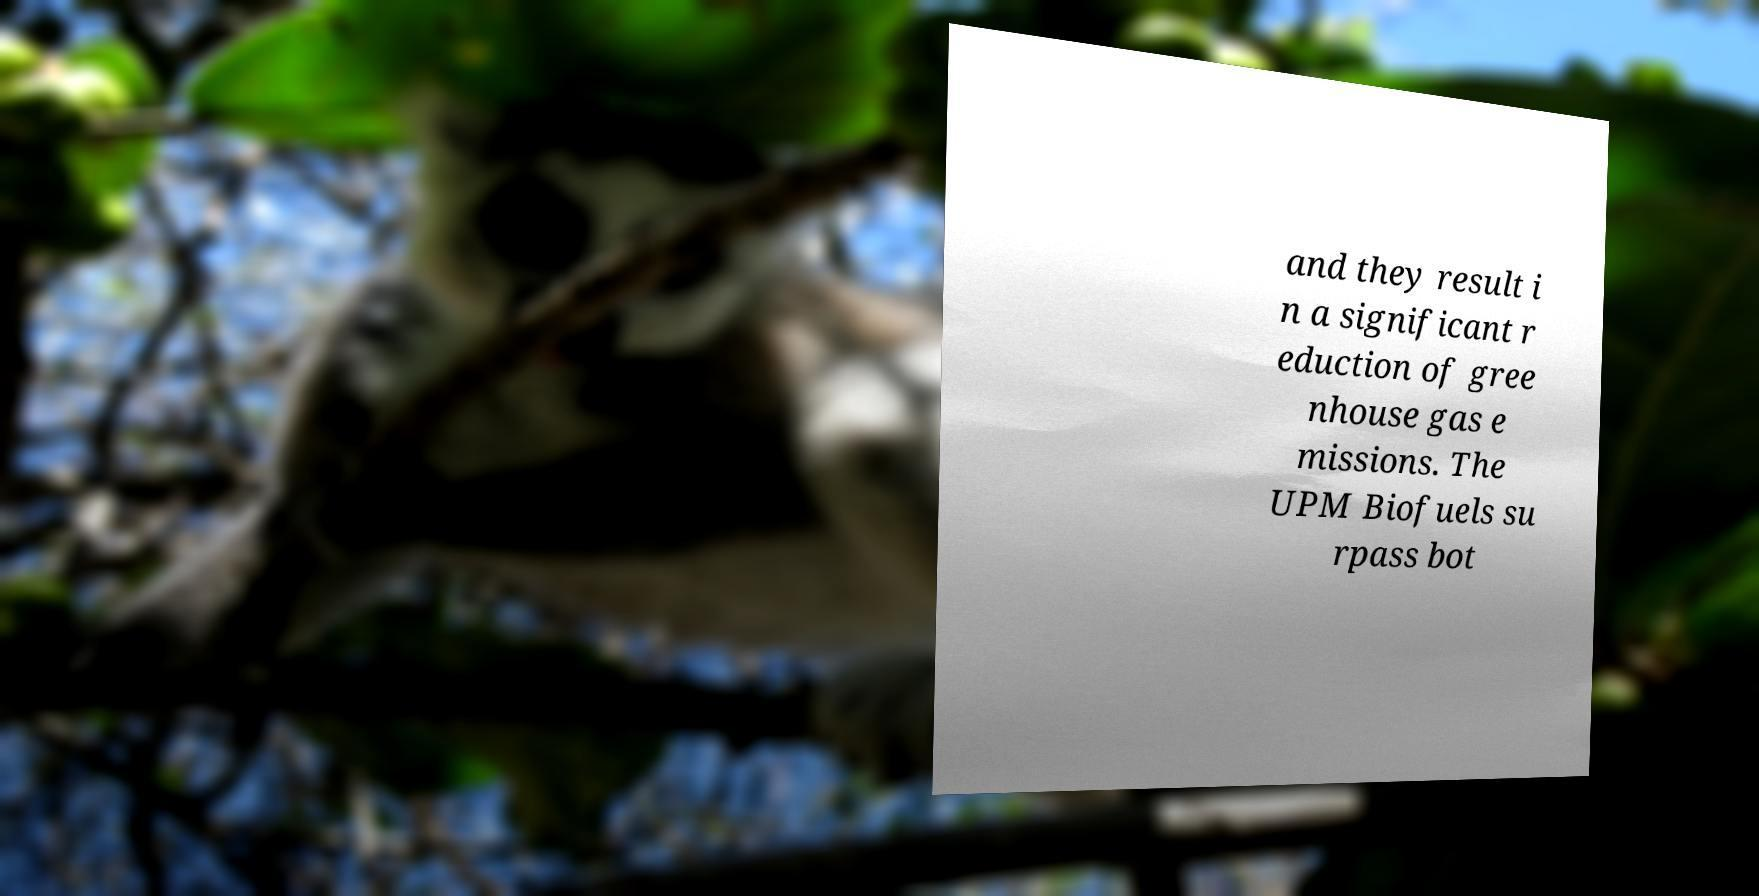Could you assist in decoding the text presented in this image and type it out clearly? and they result i n a significant r eduction of gree nhouse gas e missions. The UPM Biofuels su rpass bot 